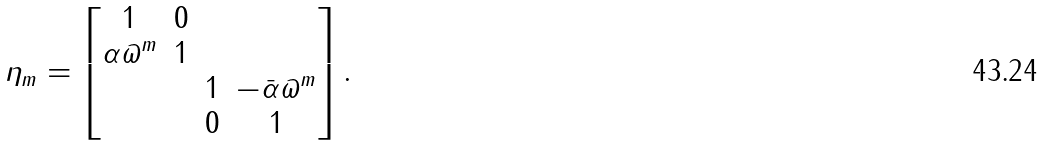<formula> <loc_0><loc_0><loc_500><loc_500>\eta _ { m } = \begin{bmatrix} 1 & 0 & & \\ \alpha \varpi ^ { m } & 1 & & \\ & & 1 & - \bar { \alpha } \varpi ^ { m } \\ & & 0 & 1 \end{bmatrix} .</formula> 